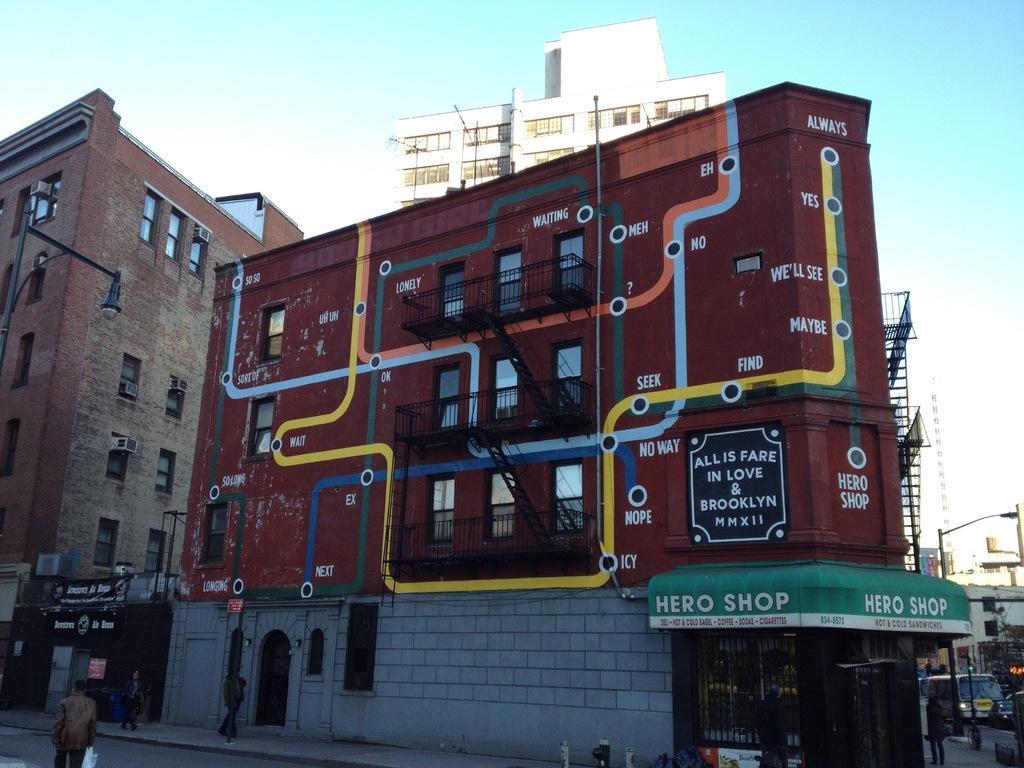In one or two sentences, can you explain what this image depicts? This image is taken outdoors. At the top of the image there is the sky with clouds. At the bottom of the image there is a road. A few are walking on the sidewalk and a few are walking on the road. On the right side of the image there are a few buildings. A few vehicles are moving on the road and there is a pole with a street light. In the middle of the image there are a few buildings with walls, windows, doors, railings and roofs. There are many boards with text on them. 